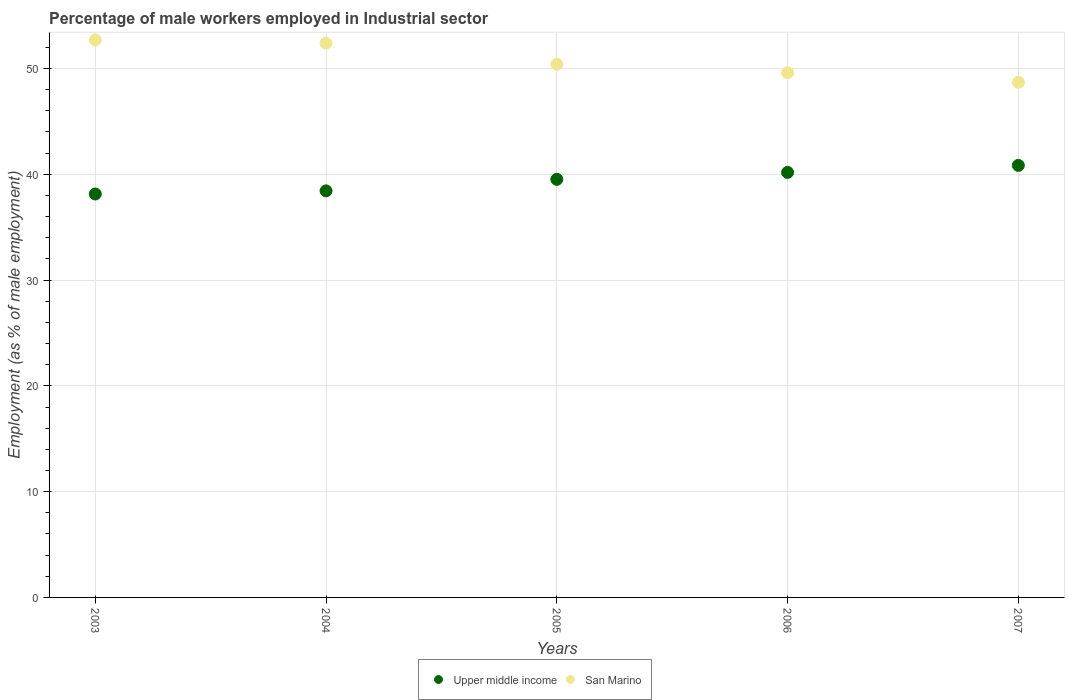How many different coloured dotlines are there?
Offer a terse response. 2. Is the number of dotlines equal to the number of legend labels?
Give a very brief answer. Yes. What is the percentage of male workers employed in Industrial sector in San Marino in 2004?
Provide a short and direct response. 52.4. Across all years, what is the maximum percentage of male workers employed in Industrial sector in San Marino?
Provide a succinct answer. 52.7. Across all years, what is the minimum percentage of male workers employed in Industrial sector in San Marino?
Your response must be concise. 48.7. In which year was the percentage of male workers employed in Industrial sector in San Marino minimum?
Your response must be concise. 2007. What is the total percentage of male workers employed in Industrial sector in Upper middle income in the graph?
Provide a succinct answer. 197.11. What is the difference between the percentage of male workers employed in Industrial sector in Upper middle income in 2004 and that in 2005?
Give a very brief answer. -1.09. What is the difference between the percentage of male workers employed in Industrial sector in Upper middle income in 2005 and the percentage of male workers employed in Industrial sector in San Marino in 2007?
Your answer should be compact. -9.18. What is the average percentage of male workers employed in Industrial sector in Upper middle income per year?
Provide a succinct answer. 39.42. In the year 2007, what is the difference between the percentage of male workers employed in Industrial sector in Upper middle income and percentage of male workers employed in Industrial sector in San Marino?
Offer a terse response. -7.86. What is the ratio of the percentage of male workers employed in Industrial sector in Upper middle income in 2003 to that in 2007?
Give a very brief answer. 0.93. What is the difference between the highest and the second highest percentage of male workers employed in Industrial sector in San Marino?
Keep it short and to the point. 0.3. Is the sum of the percentage of male workers employed in Industrial sector in San Marino in 2004 and 2005 greater than the maximum percentage of male workers employed in Industrial sector in Upper middle income across all years?
Make the answer very short. Yes. Does the percentage of male workers employed in Industrial sector in Upper middle income monotonically increase over the years?
Make the answer very short. Yes. Is the percentage of male workers employed in Industrial sector in Upper middle income strictly greater than the percentage of male workers employed in Industrial sector in San Marino over the years?
Provide a short and direct response. No. How many dotlines are there?
Offer a very short reply. 2. How are the legend labels stacked?
Your response must be concise. Horizontal. What is the title of the graph?
Your answer should be compact. Percentage of male workers employed in Industrial sector. What is the label or title of the Y-axis?
Give a very brief answer. Employment (as % of male employment). What is the Employment (as % of male employment) of Upper middle income in 2003?
Offer a terse response. 38.14. What is the Employment (as % of male employment) of San Marino in 2003?
Offer a terse response. 52.7. What is the Employment (as % of male employment) in Upper middle income in 2004?
Offer a terse response. 38.43. What is the Employment (as % of male employment) of San Marino in 2004?
Give a very brief answer. 52.4. What is the Employment (as % of male employment) of Upper middle income in 2005?
Offer a terse response. 39.52. What is the Employment (as % of male employment) of San Marino in 2005?
Keep it short and to the point. 50.4. What is the Employment (as % of male employment) of Upper middle income in 2006?
Offer a very short reply. 40.18. What is the Employment (as % of male employment) in San Marino in 2006?
Provide a short and direct response. 49.6. What is the Employment (as % of male employment) of Upper middle income in 2007?
Make the answer very short. 40.84. What is the Employment (as % of male employment) in San Marino in 2007?
Make the answer very short. 48.7. Across all years, what is the maximum Employment (as % of male employment) of Upper middle income?
Provide a short and direct response. 40.84. Across all years, what is the maximum Employment (as % of male employment) of San Marino?
Offer a very short reply. 52.7. Across all years, what is the minimum Employment (as % of male employment) in Upper middle income?
Keep it short and to the point. 38.14. Across all years, what is the minimum Employment (as % of male employment) in San Marino?
Provide a succinct answer. 48.7. What is the total Employment (as % of male employment) in Upper middle income in the graph?
Your answer should be compact. 197.11. What is the total Employment (as % of male employment) of San Marino in the graph?
Provide a short and direct response. 253.8. What is the difference between the Employment (as % of male employment) in Upper middle income in 2003 and that in 2004?
Provide a short and direct response. -0.29. What is the difference between the Employment (as % of male employment) of Upper middle income in 2003 and that in 2005?
Ensure brevity in your answer.  -1.39. What is the difference between the Employment (as % of male employment) in San Marino in 2003 and that in 2005?
Provide a succinct answer. 2.3. What is the difference between the Employment (as % of male employment) of Upper middle income in 2003 and that in 2006?
Offer a very short reply. -2.04. What is the difference between the Employment (as % of male employment) of Upper middle income in 2003 and that in 2007?
Your answer should be compact. -2.7. What is the difference between the Employment (as % of male employment) of Upper middle income in 2004 and that in 2005?
Your answer should be compact. -1.09. What is the difference between the Employment (as % of male employment) in San Marino in 2004 and that in 2005?
Keep it short and to the point. 2. What is the difference between the Employment (as % of male employment) of Upper middle income in 2004 and that in 2006?
Make the answer very short. -1.75. What is the difference between the Employment (as % of male employment) in Upper middle income in 2004 and that in 2007?
Provide a short and direct response. -2.41. What is the difference between the Employment (as % of male employment) of Upper middle income in 2005 and that in 2006?
Your response must be concise. -0.66. What is the difference between the Employment (as % of male employment) in San Marino in 2005 and that in 2006?
Offer a very short reply. 0.8. What is the difference between the Employment (as % of male employment) of Upper middle income in 2005 and that in 2007?
Give a very brief answer. -1.32. What is the difference between the Employment (as % of male employment) in San Marino in 2005 and that in 2007?
Provide a succinct answer. 1.7. What is the difference between the Employment (as % of male employment) of Upper middle income in 2006 and that in 2007?
Make the answer very short. -0.66. What is the difference between the Employment (as % of male employment) of Upper middle income in 2003 and the Employment (as % of male employment) of San Marino in 2004?
Make the answer very short. -14.26. What is the difference between the Employment (as % of male employment) of Upper middle income in 2003 and the Employment (as % of male employment) of San Marino in 2005?
Your answer should be very brief. -12.26. What is the difference between the Employment (as % of male employment) in Upper middle income in 2003 and the Employment (as % of male employment) in San Marino in 2006?
Your answer should be very brief. -11.46. What is the difference between the Employment (as % of male employment) in Upper middle income in 2003 and the Employment (as % of male employment) in San Marino in 2007?
Ensure brevity in your answer.  -10.56. What is the difference between the Employment (as % of male employment) of Upper middle income in 2004 and the Employment (as % of male employment) of San Marino in 2005?
Your answer should be compact. -11.97. What is the difference between the Employment (as % of male employment) of Upper middle income in 2004 and the Employment (as % of male employment) of San Marino in 2006?
Offer a terse response. -11.17. What is the difference between the Employment (as % of male employment) in Upper middle income in 2004 and the Employment (as % of male employment) in San Marino in 2007?
Offer a terse response. -10.27. What is the difference between the Employment (as % of male employment) in Upper middle income in 2005 and the Employment (as % of male employment) in San Marino in 2006?
Provide a succinct answer. -10.08. What is the difference between the Employment (as % of male employment) of Upper middle income in 2005 and the Employment (as % of male employment) of San Marino in 2007?
Give a very brief answer. -9.18. What is the difference between the Employment (as % of male employment) of Upper middle income in 2006 and the Employment (as % of male employment) of San Marino in 2007?
Your response must be concise. -8.52. What is the average Employment (as % of male employment) in Upper middle income per year?
Offer a very short reply. 39.42. What is the average Employment (as % of male employment) of San Marino per year?
Provide a succinct answer. 50.76. In the year 2003, what is the difference between the Employment (as % of male employment) in Upper middle income and Employment (as % of male employment) in San Marino?
Keep it short and to the point. -14.56. In the year 2004, what is the difference between the Employment (as % of male employment) of Upper middle income and Employment (as % of male employment) of San Marino?
Ensure brevity in your answer.  -13.97. In the year 2005, what is the difference between the Employment (as % of male employment) in Upper middle income and Employment (as % of male employment) in San Marino?
Keep it short and to the point. -10.88. In the year 2006, what is the difference between the Employment (as % of male employment) in Upper middle income and Employment (as % of male employment) in San Marino?
Your answer should be compact. -9.42. In the year 2007, what is the difference between the Employment (as % of male employment) of Upper middle income and Employment (as % of male employment) of San Marino?
Your answer should be very brief. -7.86. What is the ratio of the Employment (as % of male employment) of Upper middle income in 2003 to that in 2004?
Provide a succinct answer. 0.99. What is the ratio of the Employment (as % of male employment) in Upper middle income in 2003 to that in 2005?
Make the answer very short. 0.96. What is the ratio of the Employment (as % of male employment) in San Marino in 2003 to that in 2005?
Ensure brevity in your answer.  1.05. What is the ratio of the Employment (as % of male employment) in Upper middle income in 2003 to that in 2006?
Your response must be concise. 0.95. What is the ratio of the Employment (as % of male employment) in San Marino in 2003 to that in 2006?
Your answer should be very brief. 1.06. What is the ratio of the Employment (as % of male employment) of Upper middle income in 2003 to that in 2007?
Offer a terse response. 0.93. What is the ratio of the Employment (as % of male employment) in San Marino in 2003 to that in 2007?
Make the answer very short. 1.08. What is the ratio of the Employment (as % of male employment) of Upper middle income in 2004 to that in 2005?
Ensure brevity in your answer.  0.97. What is the ratio of the Employment (as % of male employment) in San Marino in 2004 to that in 2005?
Your answer should be very brief. 1.04. What is the ratio of the Employment (as % of male employment) in Upper middle income in 2004 to that in 2006?
Give a very brief answer. 0.96. What is the ratio of the Employment (as % of male employment) in San Marino in 2004 to that in 2006?
Offer a terse response. 1.06. What is the ratio of the Employment (as % of male employment) of Upper middle income in 2004 to that in 2007?
Make the answer very short. 0.94. What is the ratio of the Employment (as % of male employment) in San Marino in 2004 to that in 2007?
Your answer should be compact. 1.08. What is the ratio of the Employment (as % of male employment) of Upper middle income in 2005 to that in 2006?
Your answer should be very brief. 0.98. What is the ratio of the Employment (as % of male employment) in San Marino in 2005 to that in 2006?
Offer a terse response. 1.02. What is the ratio of the Employment (as % of male employment) of Upper middle income in 2005 to that in 2007?
Your response must be concise. 0.97. What is the ratio of the Employment (as % of male employment) of San Marino in 2005 to that in 2007?
Your response must be concise. 1.03. What is the ratio of the Employment (as % of male employment) in Upper middle income in 2006 to that in 2007?
Your answer should be compact. 0.98. What is the ratio of the Employment (as % of male employment) of San Marino in 2006 to that in 2007?
Provide a short and direct response. 1.02. What is the difference between the highest and the second highest Employment (as % of male employment) of Upper middle income?
Provide a short and direct response. 0.66. What is the difference between the highest and the lowest Employment (as % of male employment) of Upper middle income?
Keep it short and to the point. 2.7. 